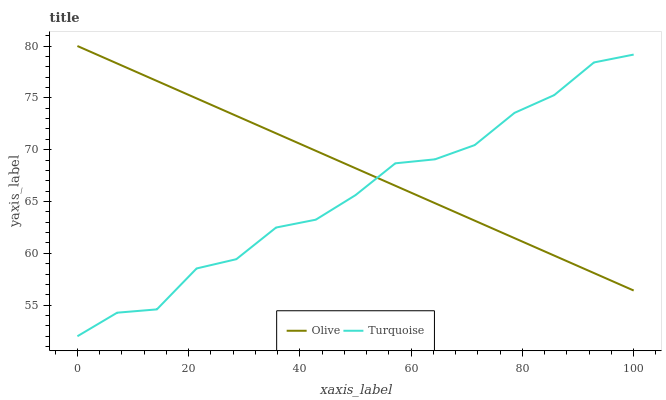Does Turquoise have the minimum area under the curve?
Answer yes or no. Yes. Does Olive have the maximum area under the curve?
Answer yes or no. Yes. Does Turquoise have the maximum area under the curve?
Answer yes or no. No. Is Olive the smoothest?
Answer yes or no. Yes. Is Turquoise the roughest?
Answer yes or no. Yes. Is Turquoise the smoothest?
Answer yes or no. No. Does Turquoise have the lowest value?
Answer yes or no. Yes. Does Olive have the highest value?
Answer yes or no. Yes. Does Turquoise have the highest value?
Answer yes or no. No. Does Turquoise intersect Olive?
Answer yes or no. Yes. Is Turquoise less than Olive?
Answer yes or no. No. Is Turquoise greater than Olive?
Answer yes or no. No. 